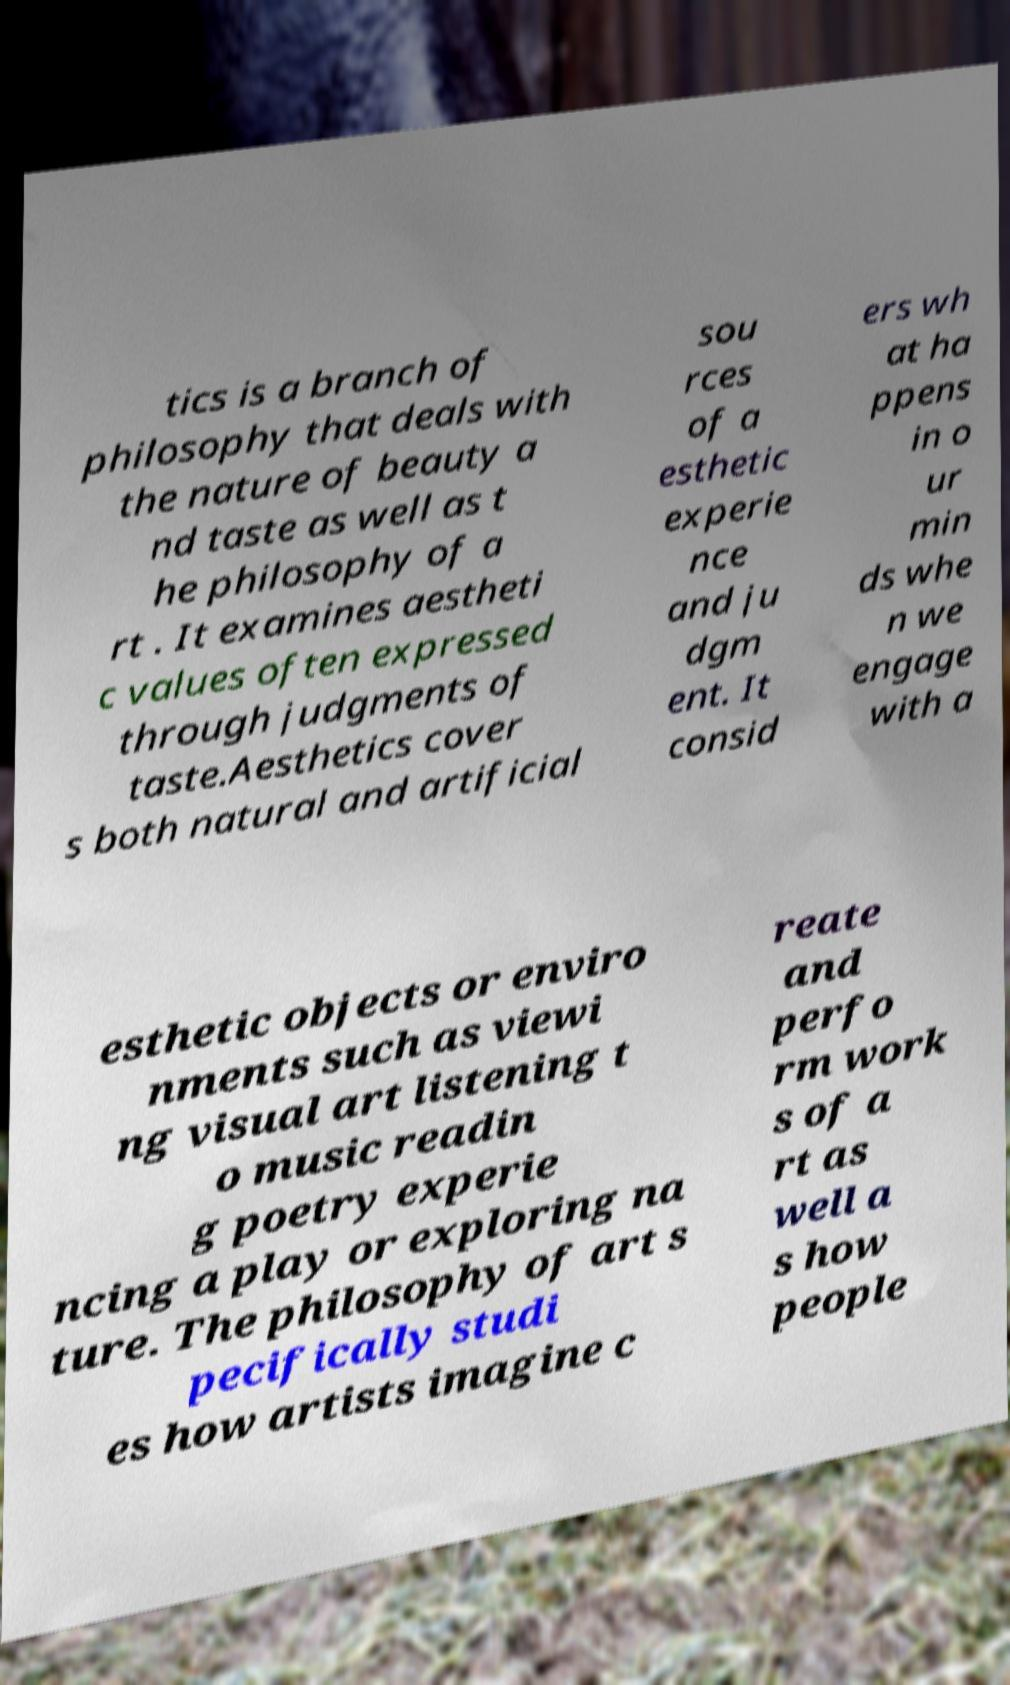Could you assist in decoding the text presented in this image and type it out clearly? tics is a branch of philosophy that deals with the nature of beauty a nd taste as well as t he philosophy of a rt . It examines aestheti c values often expressed through judgments of taste.Aesthetics cover s both natural and artificial sou rces of a esthetic experie nce and ju dgm ent. It consid ers wh at ha ppens in o ur min ds whe n we engage with a esthetic objects or enviro nments such as viewi ng visual art listening t o music readin g poetry experie ncing a play or exploring na ture. The philosophy of art s pecifically studi es how artists imagine c reate and perfo rm work s of a rt as well a s how people 